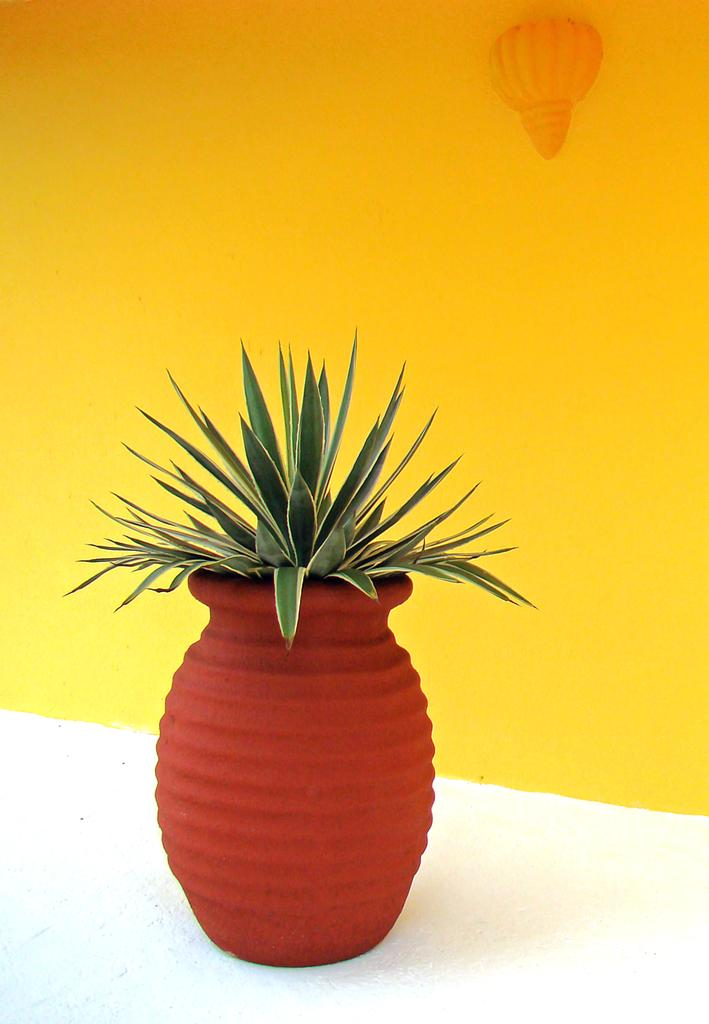What is in the image that can hold a plant? There is a pot in the image that can hold a plant. What is inside the pot? There is a plant in the pot. What can be seen behind the pot in the image? There is a wall visible in the image. What color is the wall? The wall is yellow in color. What type of floor can be seen in the image? There is no floor visible in the image; it only shows a pot with a plant and a yellow wall. 